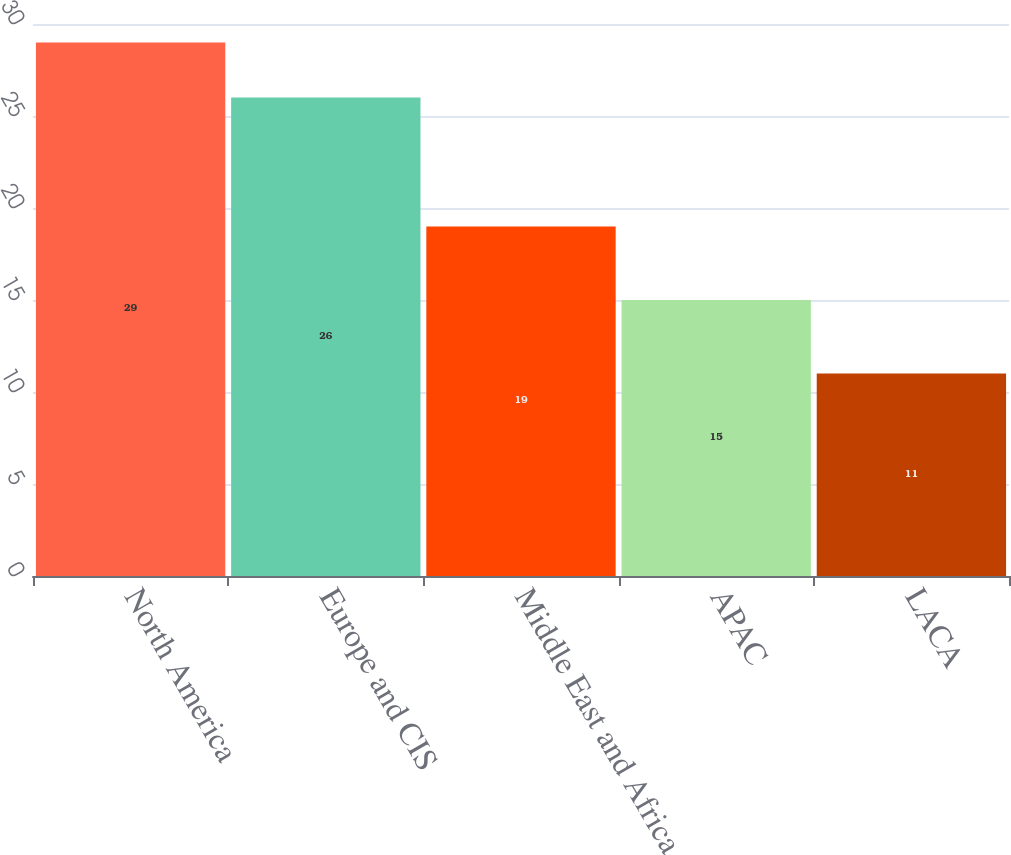Convert chart to OTSL. <chart><loc_0><loc_0><loc_500><loc_500><bar_chart><fcel>North America<fcel>Europe and CIS<fcel>Middle East and Africa<fcel>APAC<fcel>LACA<nl><fcel>29<fcel>26<fcel>19<fcel>15<fcel>11<nl></chart> 